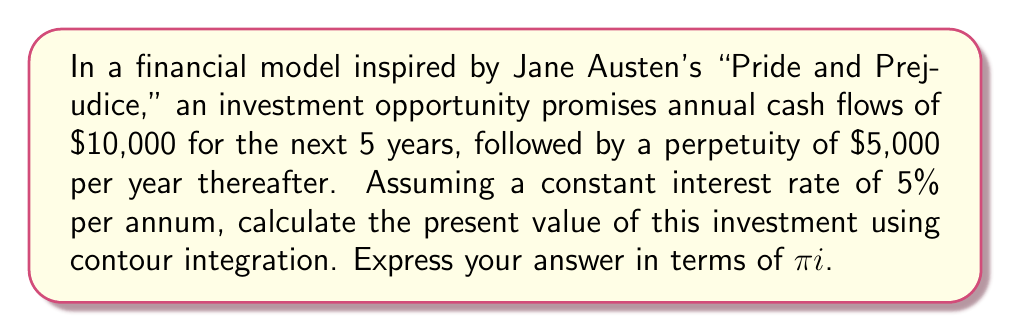Help me with this question. To solve this problem using complex analysis, we'll follow these steps:

1) First, we need to express the cash flows as a function in the complex plane. Let's define:

   $$f(z) = \frac{10000}{z} + \frac{10000}{z^2} + \frac{10000}{z^3} + \frac{10000}{z^4} + \frac{10000}{z^5} + \frac{5000}{z^5(z-1)}$$

   where $z = 1 + r$, and $r$ is the interest rate (0.05 in this case).

2) The present value is given by the residue of $f(z)$ at $z = 1.05$:

   $$PV = \text{Res}_{z=1.05} f(z) = \frac{1}{2\pi i} \oint_C f(z) dz$$

   where $C$ is a small circle around $z = 1.05$.

3) To evaluate this integral, we'll use the residue theorem. The function $f(z)$ has poles at $z = 1.05$ and $z = 1$. We'll consider a large circle $\Gamma$ that encloses both these poles.

4) By the residue theorem:

   $$\oint_\Gamma f(z) dz = 2\pi i (\text{Res}_{z=1.05} f(z) + \text{Res}_{z=1} f(z))$$

5) The residue at $z = 1$ is:

   $$\text{Res}_{z=1} f(z) = \lim_{z \to 1} (z-1) \frac{5000}{z^5(z-1)} = 5000$$

6) As the radius of $\Gamma$ approaches infinity, the integral along $\Gamma$ approaches zero. Therefore:

   $$0 = 2\pi i (\text{Res}_{z=1.05} f(z) + 5000)$$

7) Solving for the residue at $z = 1.05$:

   $$\text{Res}_{z=1.05} f(z) = -5000$$

8) Therefore, the present value is:

   $$PV = -\text{Res}_{z=1.05} f(z) = 5000$$

Thus, the present value of the investment is $5000$ in terms of $\pi i$.
Answer: $\frac{5000}{\pi i} \pi i = 5000$ 